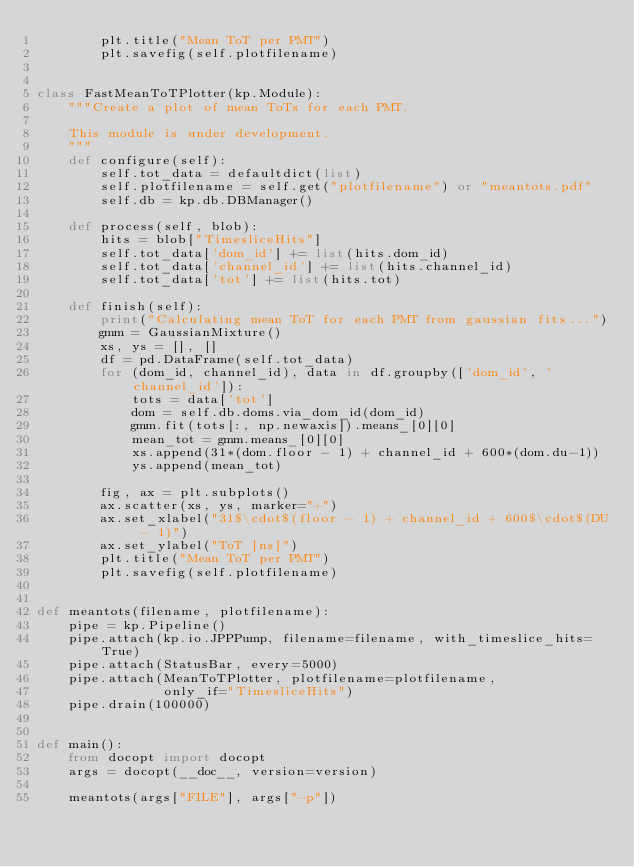Convert code to text. <code><loc_0><loc_0><loc_500><loc_500><_Python_>        plt.title("Mean ToT per PMT")
        plt.savefig(self.plotfilename)


class FastMeanToTPlotter(kp.Module):
    """Create a plot of mean ToTs for each PMT.

    This module is under development.
    """
    def configure(self):
        self.tot_data = defaultdict(list)
        self.plotfilename = self.get("plotfilename") or "meantots.pdf"
        self.db = kp.db.DBManager()

    def process(self, blob):
        hits = blob["TimesliceHits"]
        self.tot_data['dom_id'] += list(hits.dom_id)
        self.tot_data['channel_id'] += list(hits.channel_id)
        self.tot_data['tot'] += list(hits.tot)

    def finish(self):
        print("Calculating mean ToT for each PMT from gaussian fits...")
        gmm = GaussianMixture()
        xs, ys = [], []
        df = pd.DataFrame(self.tot_data)
        for (dom_id, channel_id), data in df.groupby(['dom_id', 'channel_id']):
            tots = data['tot']
            dom = self.db.doms.via_dom_id(dom_id)
            gmm.fit(tots[:, np.newaxis]).means_[0][0]
            mean_tot = gmm.means_[0][0]
            xs.append(31*(dom.floor - 1) + channel_id + 600*(dom.du-1))
            ys.append(mean_tot)

        fig, ax = plt.subplots()
        ax.scatter(xs, ys, marker="+")
        ax.set_xlabel("31$\cdot$(floor - 1) + channel_id + 600$\cdot$(DU - 1)")
        ax.set_ylabel("ToT [ns]")
        plt.title("Mean ToT per PMT")
        plt.savefig(self.plotfilename)


def meantots(filename, plotfilename):
    pipe = kp.Pipeline()
    pipe.attach(kp.io.JPPPump, filename=filename, with_timeslice_hits=True)
    pipe.attach(StatusBar, every=5000)
    pipe.attach(MeanToTPlotter, plotfilename=plotfilename,
                only_if="TimesliceHits")
    pipe.drain(100000)


def main():
    from docopt import docopt
    args = docopt(__doc__, version=version)

    meantots(args["FILE"], args["-p"])
</code> 